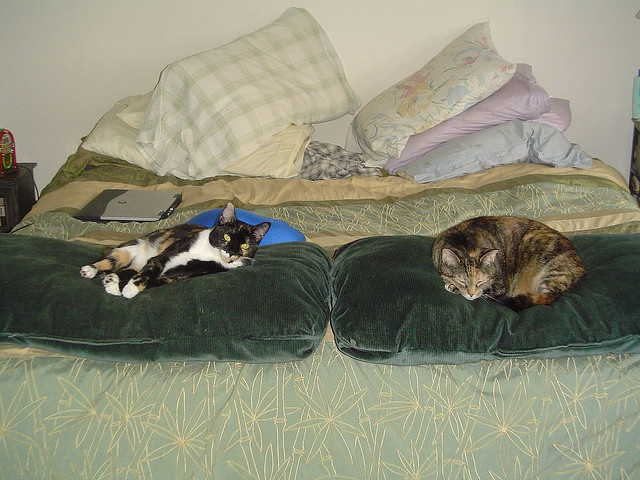Describe the objects in this image and their specific colors. I can see bed in darkgray, black, tan, and gray tones, cat in darkgray, black, olive, and gray tones, cat in darkgray, black, beige, and gray tones, and laptop in darkgray, gray, and black tones in this image. 